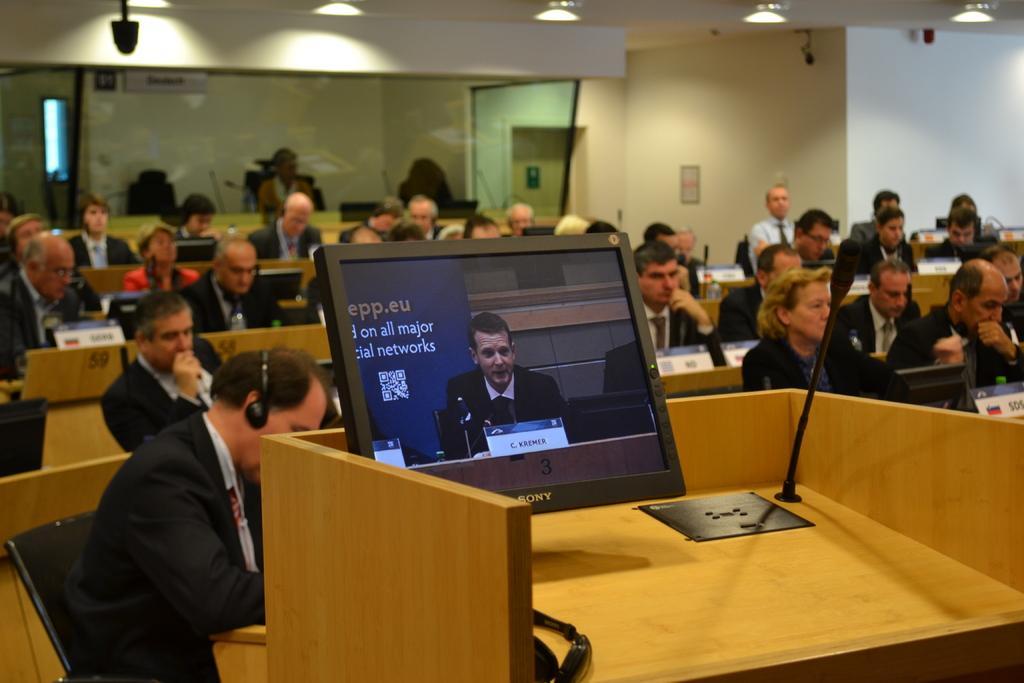In one or two sentences, can you explain what this image depicts? In this picture there are people sitting and we can see boards and microphones on tables and monitor, microphone and objects on podium. In the background of the image we can see wall, lights and glass, through glass we can see a person and board. 